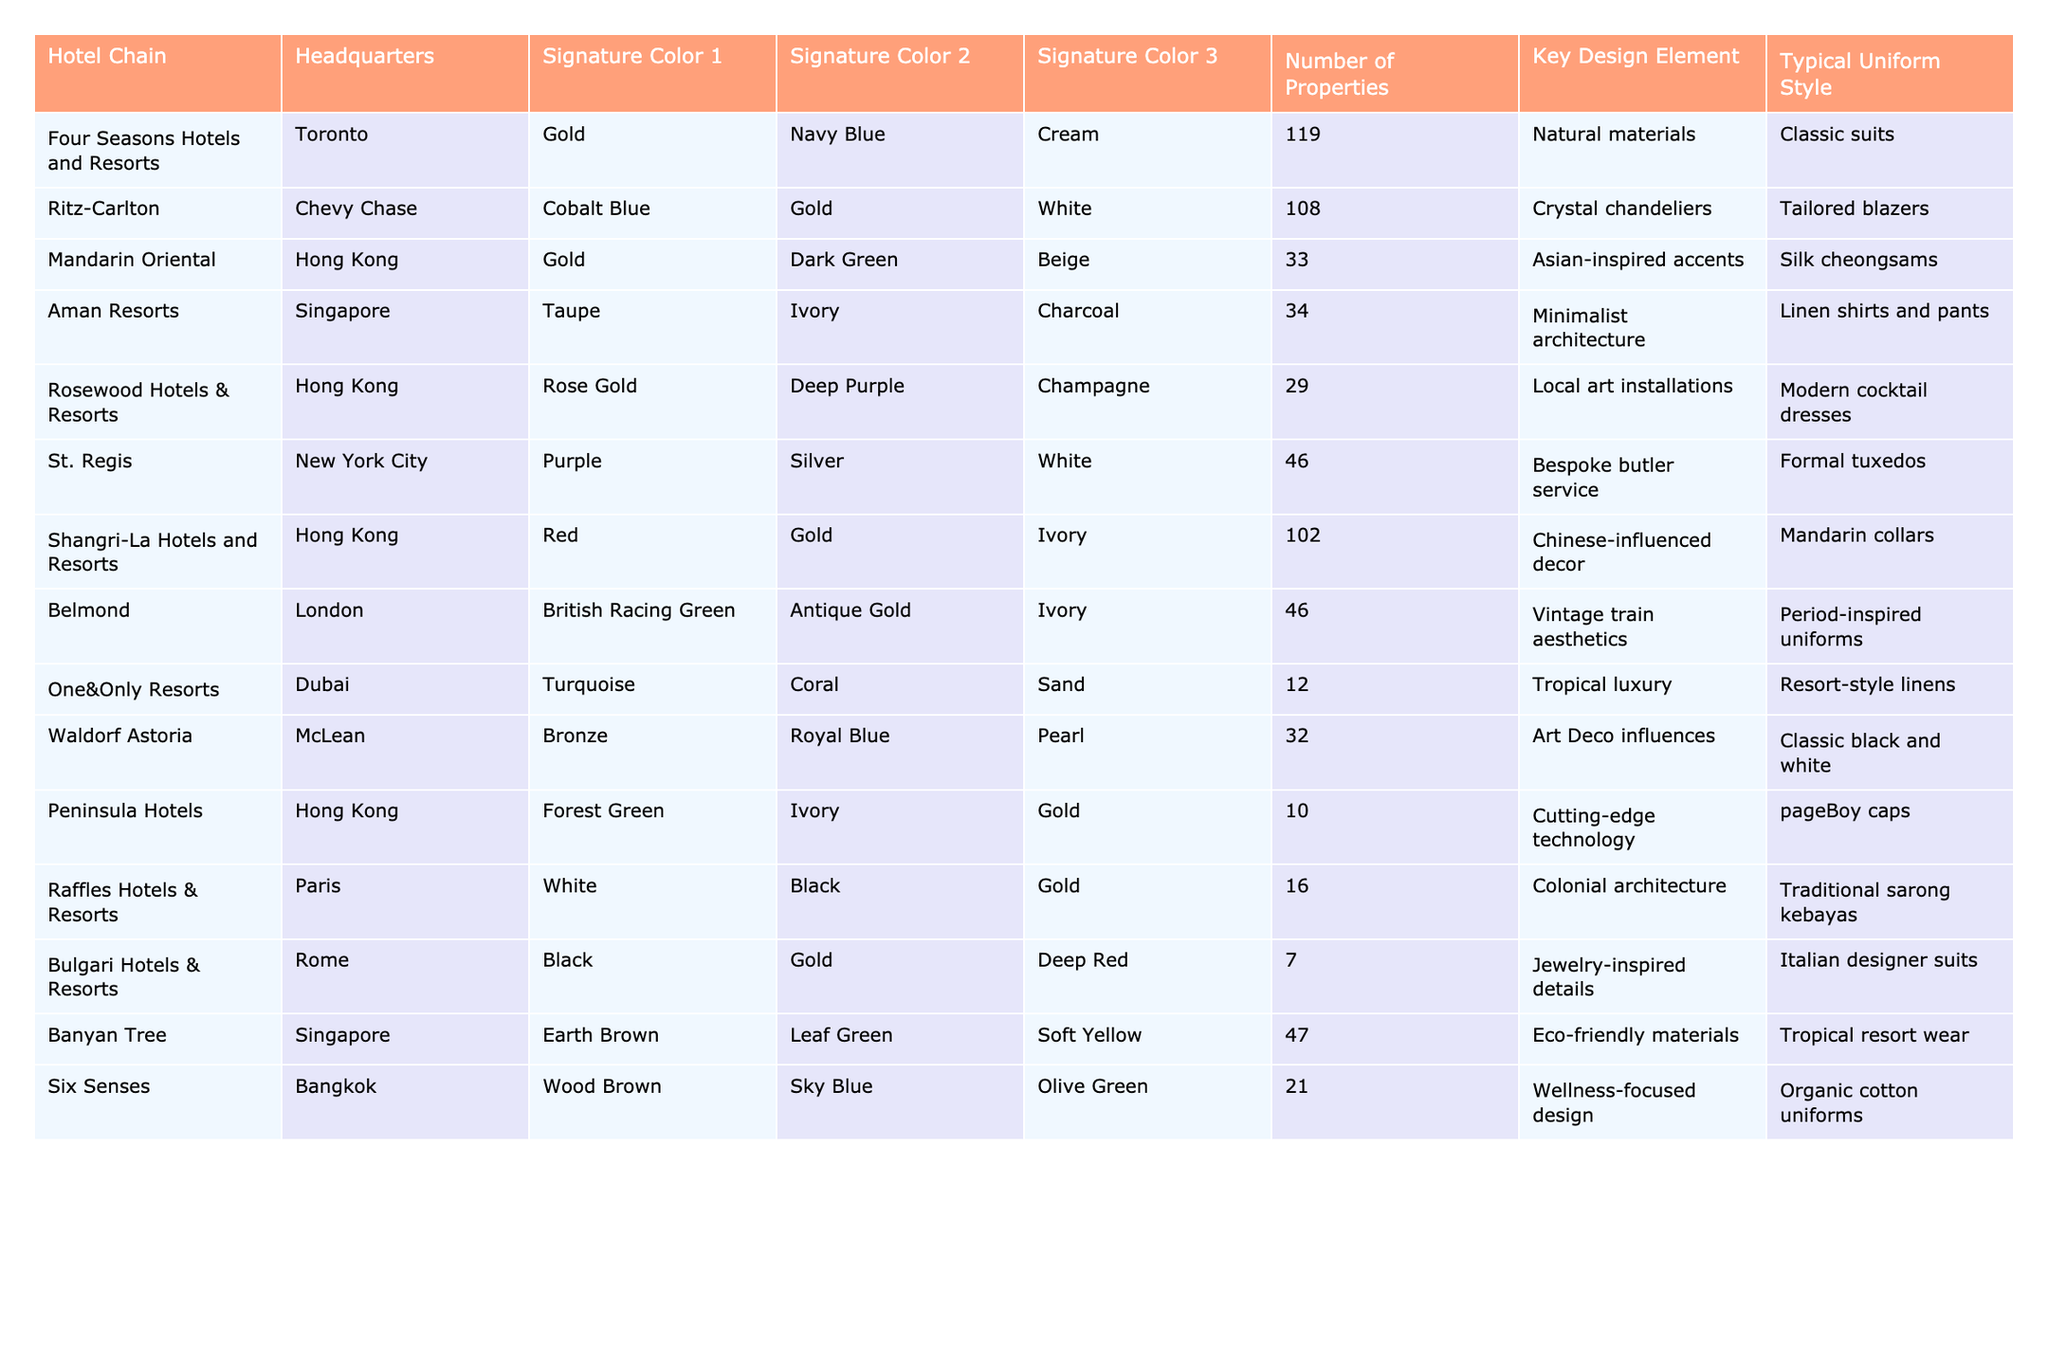What is the headquarters location of Aman Resorts? The table lists the headquarters of each hotel chain, and for Aman Resorts, it specifies Singapore.
Answer: Singapore Which hotel chain has the most properties? By reviewing the 'Number of Properties' column, Four Seasons Hotels and Resorts has 119 properties, which is the highest among all listed.
Answer: Four Seasons Hotels and Resorts Does the St. Regis hotel chain include a specific uniform style? The table indicates a 'Typical Uniform Style' for the St. Regis hotel chain, which is 'Formal tuxedos'. Therefore, the answer is yes.
Answer: Yes What are the three signature colors of Ritz-Carlton? The Ritz-Carlton's signature colors are listed in the table as Cobalt Blue, Gold, and White.
Answer: Cobalt Blue, Gold, White Which hotel chain features a design element focusing on 'Asian-inspired accents'? The table indicates that Mandarin Oriental features 'Asian-inspired accents' as its key design element.
Answer: Mandarin Oriental How many hotel chains have 'Gold' as one of their signature colors? Reviewing the table, Gold appears as a signature color for Four Seasons, Ritz-Carlton, Mandarin Oriental, Shangri-La, Peninsula, Raffles, and Bulgari, totaling six chains.
Answer: 6 Which hotel chain has the smallest number of properties and what is that number? From the table, we see that Peninsula Hotels has the smallest number of properties with only 10 locations.
Answer: 10 Is it true that all hotel chains listed have a modern design element? Looking at the 'Key Design Element' column, not all chains have modern designs; for example, Raffles has 'Colonial architecture', which is not modern.
Answer: No What is the average number of properties across the listed hotel chains? The total number of properties is 119 + 108 + 33 + 34 + 29 + 46 + 102 + 46 + 12 + 32 + 10 + 16 + 7 + 47 + 21 =  598. With 15 chains, the average is 598/15 = approximately 39.87.
Answer: 39.87 Which hotel chain has the signature color 'Rose Gold' and what is its key design element? The table shows that Rosewood Hotels & Resorts has 'Rose Gold' as a signature color, and their key design element is 'Local art installations'.
Answer: Rosewood Hotels & Resorts; Local art installations 